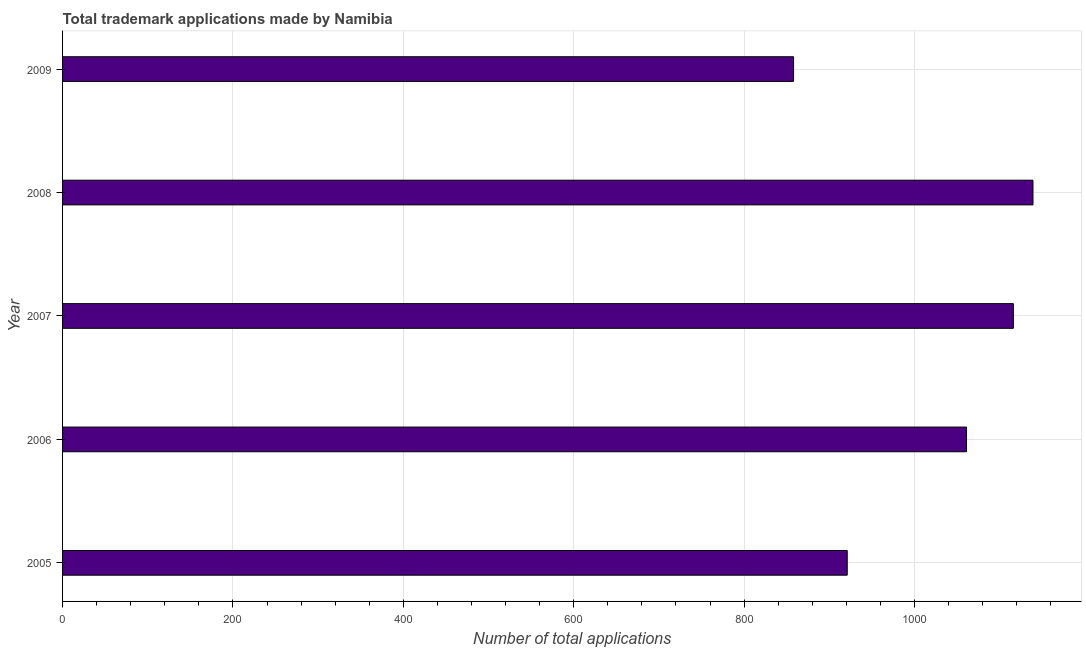Does the graph contain grids?
Your answer should be very brief. Yes. What is the title of the graph?
Your response must be concise. Total trademark applications made by Namibia. What is the label or title of the X-axis?
Your answer should be very brief. Number of total applications. What is the number of trademark applications in 2005?
Your answer should be compact. 921. Across all years, what is the maximum number of trademark applications?
Keep it short and to the point. 1139. Across all years, what is the minimum number of trademark applications?
Ensure brevity in your answer.  858. In which year was the number of trademark applications maximum?
Give a very brief answer. 2008. What is the sum of the number of trademark applications?
Provide a succinct answer. 5095. What is the difference between the number of trademark applications in 2005 and 2006?
Ensure brevity in your answer.  -140. What is the average number of trademark applications per year?
Offer a terse response. 1019. What is the median number of trademark applications?
Ensure brevity in your answer.  1061. In how many years, is the number of trademark applications greater than 560 ?
Offer a terse response. 5. Do a majority of the years between 2006 and 2005 (inclusive) have number of trademark applications greater than 560 ?
Your answer should be compact. No. What is the ratio of the number of trademark applications in 2005 to that in 2007?
Ensure brevity in your answer.  0.82. Is the difference between the number of trademark applications in 2007 and 2009 greater than the difference between any two years?
Ensure brevity in your answer.  No. What is the difference between the highest and the second highest number of trademark applications?
Provide a succinct answer. 23. Is the sum of the number of trademark applications in 2006 and 2008 greater than the maximum number of trademark applications across all years?
Provide a succinct answer. Yes. What is the difference between the highest and the lowest number of trademark applications?
Offer a very short reply. 281. In how many years, is the number of trademark applications greater than the average number of trademark applications taken over all years?
Offer a terse response. 3. How many bars are there?
Give a very brief answer. 5. What is the difference between two consecutive major ticks on the X-axis?
Provide a succinct answer. 200. What is the Number of total applications of 2005?
Offer a very short reply. 921. What is the Number of total applications in 2006?
Keep it short and to the point. 1061. What is the Number of total applications of 2007?
Keep it short and to the point. 1116. What is the Number of total applications in 2008?
Your answer should be compact. 1139. What is the Number of total applications of 2009?
Ensure brevity in your answer.  858. What is the difference between the Number of total applications in 2005 and 2006?
Provide a succinct answer. -140. What is the difference between the Number of total applications in 2005 and 2007?
Give a very brief answer. -195. What is the difference between the Number of total applications in 2005 and 2008?
Offer a very short reply. -218. What is the difference between the Number of total applications in 2005 and 2009?
Provide a short and direct response. 63. What is the difference between the Number of total applications in 2006 and 2007?
Your response must be concise. -55. What is the difference between the Number of total applications in 2006 and 2008?
Provide a succinct answer. -78. What is the difference between the Number of total applications in 2006 and 2009?
Provide a short and direct response. 203. What is the difference between the Number of total applications in 2007 and 2009?
Your answer should be very brief. 258. What is the difference between the Number of total applications in 2008 and 2009?
Offer a very short reply. 281. What is the ratio of the Number of total applications in 2005 to that in 2006?
Offer a very short reply. 0.87. What is the ratio of the Number of total applications in 2005 to that in 2007?
Make the answer very short. 0.82. What is the ratio of the Number of total applications in 2005 to that in 2008?
Your answer should be very brief. 0.81. What is the ratio of the Number of total applications in 2005 to that in 2009?
Give a very brief answer. 1.07. What is the ratio of the Number of total applications in 2006 to that in 2007?
Keep it short and to the point. 0.95. What is the ratio of the Number of total applications in 2006 to that in 2008?
Your response must be concise. 0.93. What is the ratio of the Number of total applications in 2006 to that in 2009?
Your response must be concise. 1.24. What is the ratio of the Number of total applications in 2007 to that in 2008?
Your response must be concise. 0.98. What is the ratio of the Number of total applications in 2007 to that in 2009?
Your response must be concise. 1.3. What is the ratio of the Number of total applications in 2008 to that in 2009?
Provide a short and direct response. 1.33. 